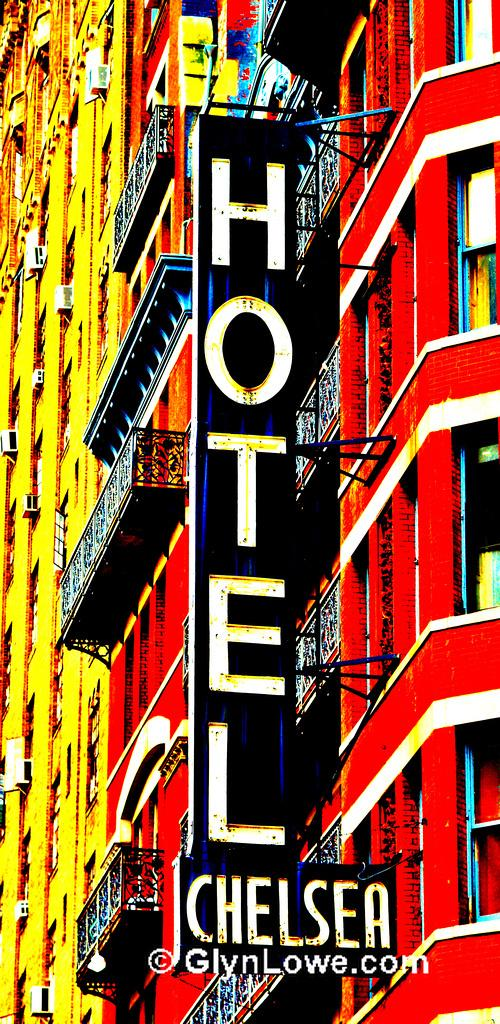What type of structure is in the image? There is a building in the image. What features can be seen on the building? The building has windows, a railing, and boards attached to it. What colors are used for the building? The building is in yellow and red color. What is the title of the governor's speech in the image? There is no governor or speech present in the image; it features a building with specific features and colors. 